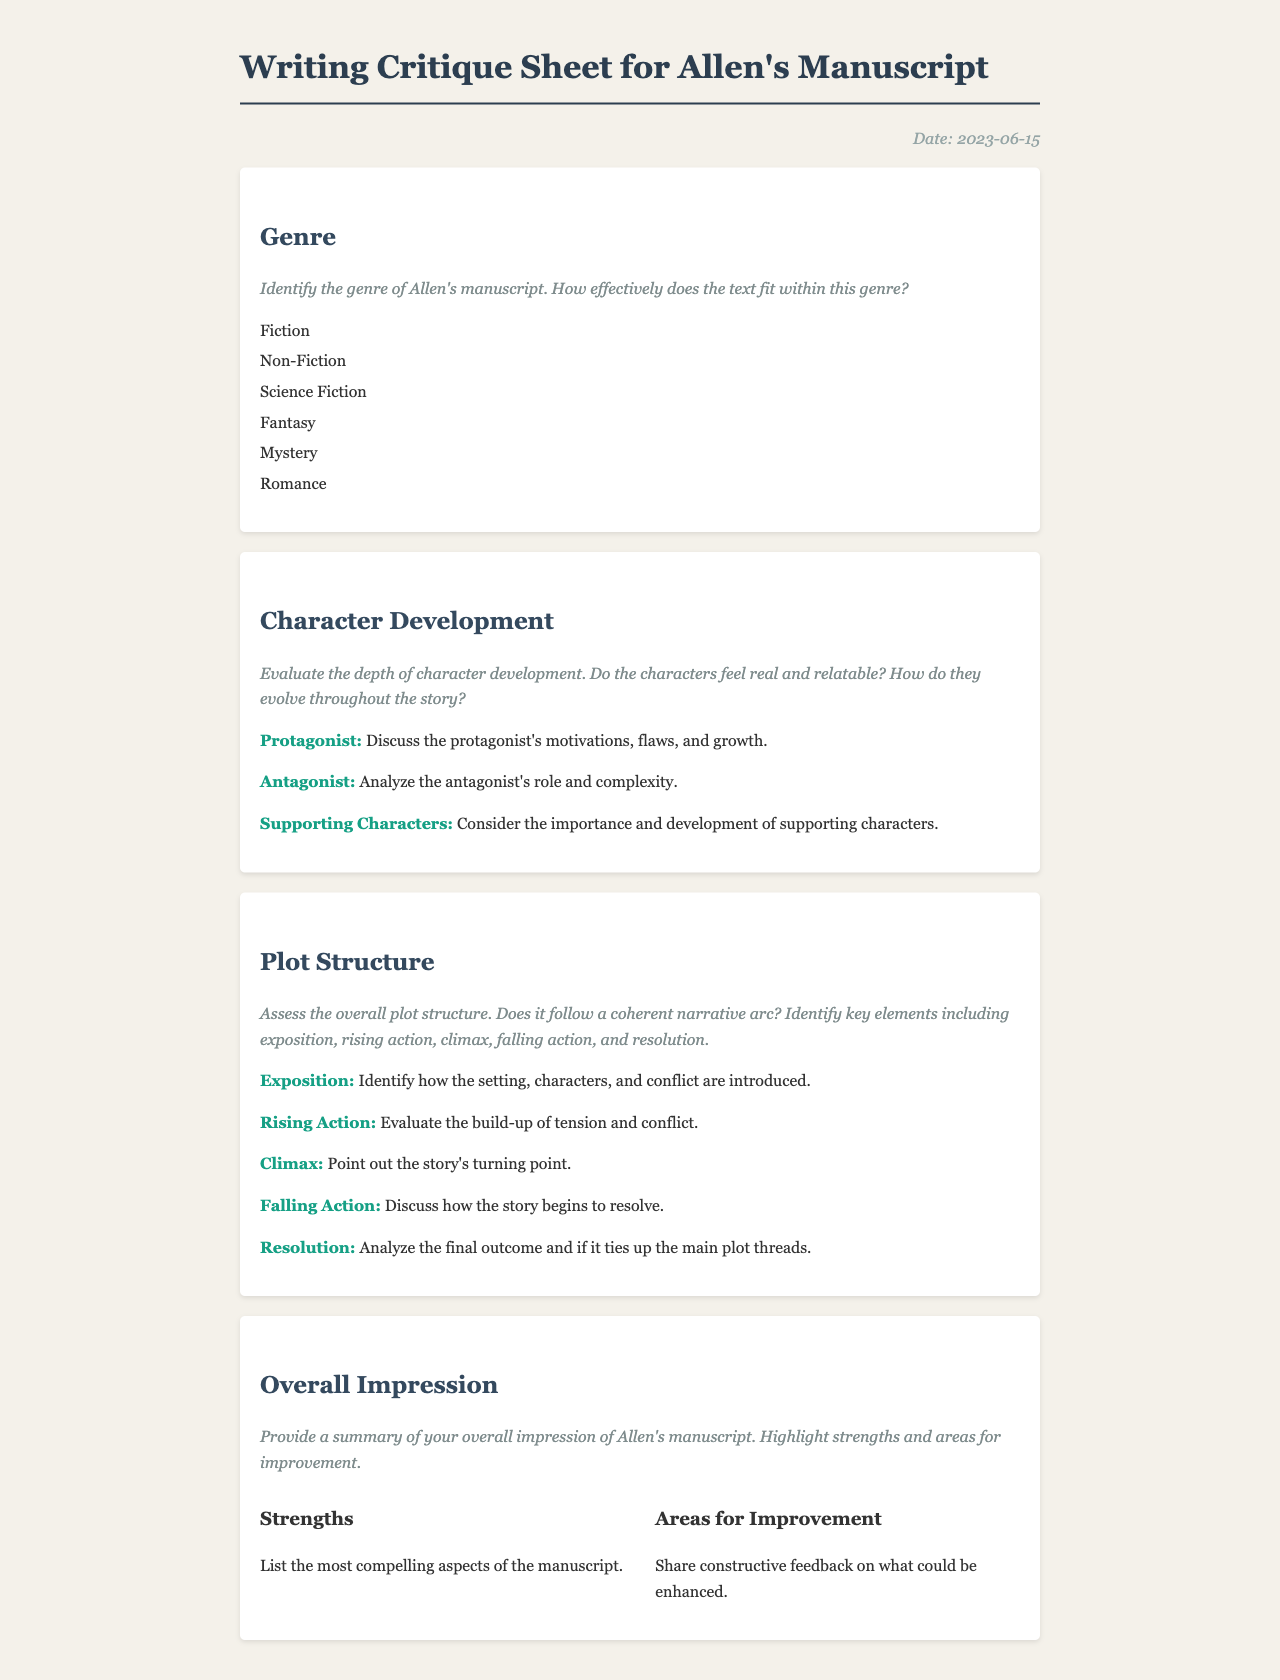what is the title of the document? The title appears prominently at the top of the document, indicating the purpose of the content.
Answer: Writing Critique Sheet for Allen's Manuscript when was the critique sheet created? The creation date is noted in the date section of the document.
Answer: 2023-06-15 what genre categories are listed in the document? The genres are outlined in a specific section to facilitate easy identification.
Answer: Fiction, Non-Fiction, Science Fiction, Fantasy, Mystery, Romance which character aspect is emphasized in the critique? The document clearly delineates the focus areas for character evaluation within the character development section.
Answer: Protagonist, Antagonist, Supporting Characters what are the key plot structure elements mentioned? This includes categories essential for evaluating the manuscript's narrative flow.
Answer: Exposition, Rising Action, Climax, Falling Action, Resolution what section comes after Character Development? This sequential arrangement indicates the flow of analysis in the document.
Answer: Plot Structure what are the two main components in the Overall Impression section? This section articulates both strengths and areas for improvement, crucial for constructive feedback.
Answer: Strengths, Areas for Improvement how many genre options are provided in the document? The list of genres presents multiple choices, indicating a diverse range of narrative styles.
Answer: 6 which color is used for the heading text in the document? The consistent use of color for headings enhances the visual structure of the document.
Answer: #34495e 